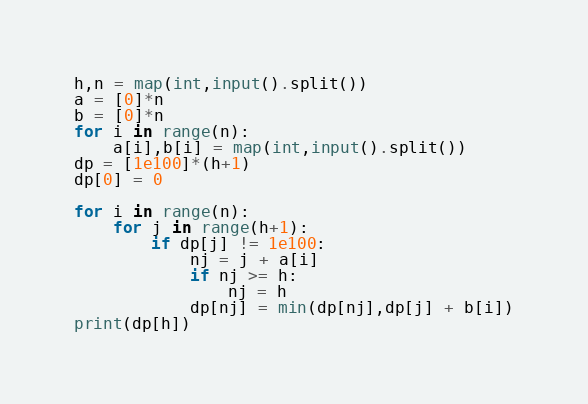Convert code to text. <code><loc_0><loc_0><loc_500><loc_500><_Python_>h,n = map(int,input().split())
a = [0]*n
b = [0]*n
for i in range(n):
    a[i],b[i] = map(int,input().split())
dp = [1e100]*(h+1)
dp[0] = 0

for i in range(n):
    for j in range(h+1):
        if dp[j] != 1e100:
            nj = j + a[i]
            if nj >= h:
                nj = h
            dp[nj] = min(dp[nj],dp[j] + b[i])
print(dp[h])
</code> 